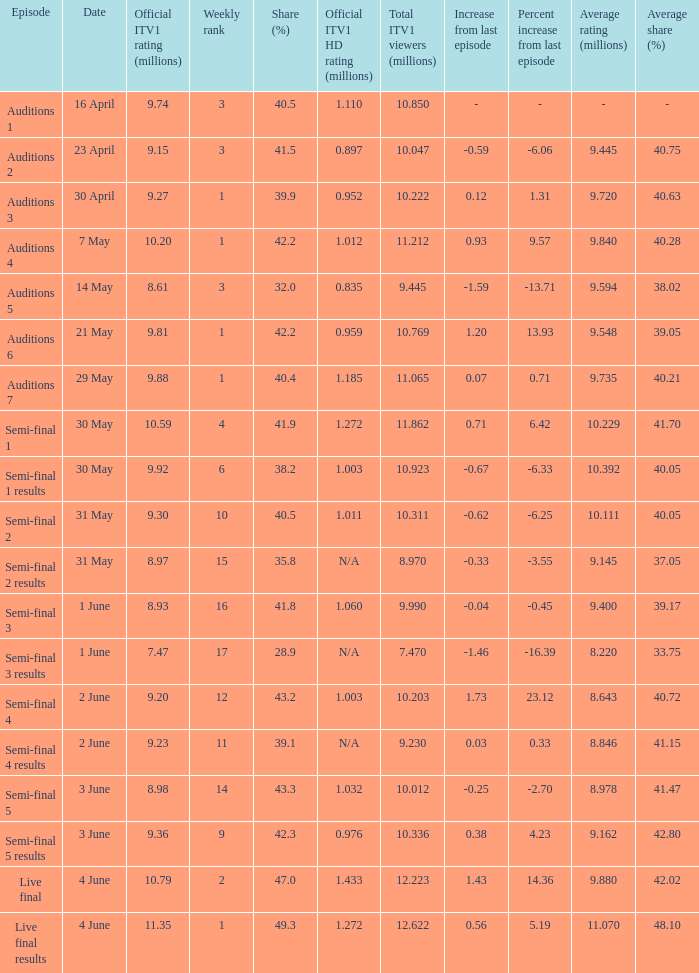What was the total ITV1 viewers in millions for the episode with a share (%) of 28.9?  7.47. 